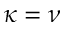<formula> <loc_0><loc_0><loc_500><loc_500>\kappa = \nu</formula> 